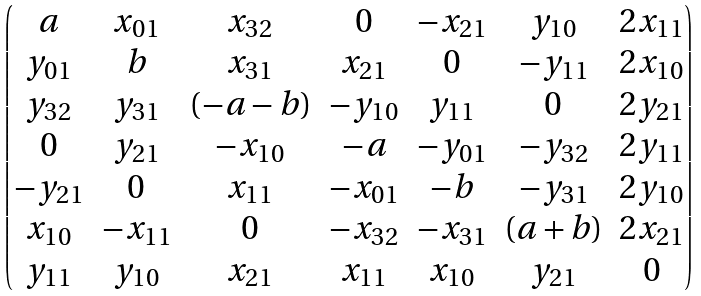Convert formula to latex. <formula><loc_0><loc_0><loc_500><loc_500>\begin{pmatrix} a & x _ { 0 1 } & x _ { 3 2 } & 0 & - x _ { 2 1 } & y _ { 1 0 } & 2 x _ { 1 1 } \\ y _ { 0 1 } & b & x _ { 3 1 } & x _ { 2 1 } & 0 & - y _ { 1 1 } & 2 x _ { 1 0 } \\ y _ { 3 2 } & y _ { 3 1 } & ( - a - b ) & - y _ { 1 0 } & y _ { 1 1 } & 0 & 2 y _ { 2 1 } \\ 0 & y _ { 2 1 } & - x _ { 1 0 } & - a & - y _ { 0 1 } & - y _ { 3 2 } & 2 y _ { 1 1 } \\ - y _ { 2 1 } & 0 & x _ { 1 1 } & - x _ { 0 1 } & - b & - y _ { 3 1 } & 2 y _ { 1 0 } \\ x _ { 1 0 } & - x _ { 1 1 } & 0 & - x _ { 3 2 } & - x _ { 3 1 } & ( a + b ) & 2 x _ { 2 1 } \\ y _ { 1 1 } & y _ { 1 0 } & x _ { 2 1 } & x _ { 1 1 } & x _ { 1 0 } & y _ { 2 1 } & 0 \end{pmatrix}</formula> 